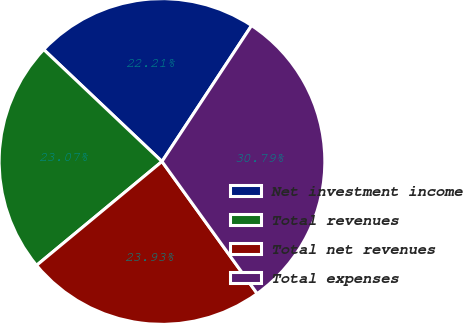Convert chart. <chart><loc_0><loc_0><loc_500><loc_500><pie_chart><fcel>Net investment income<fcel>Total revenues<fcel>Total net revenues<fcel>Total expenses<nl><fcel>22.21%<fcel>23.07%<fcel>23.93%<fcel>30.79%<nl></chart> 